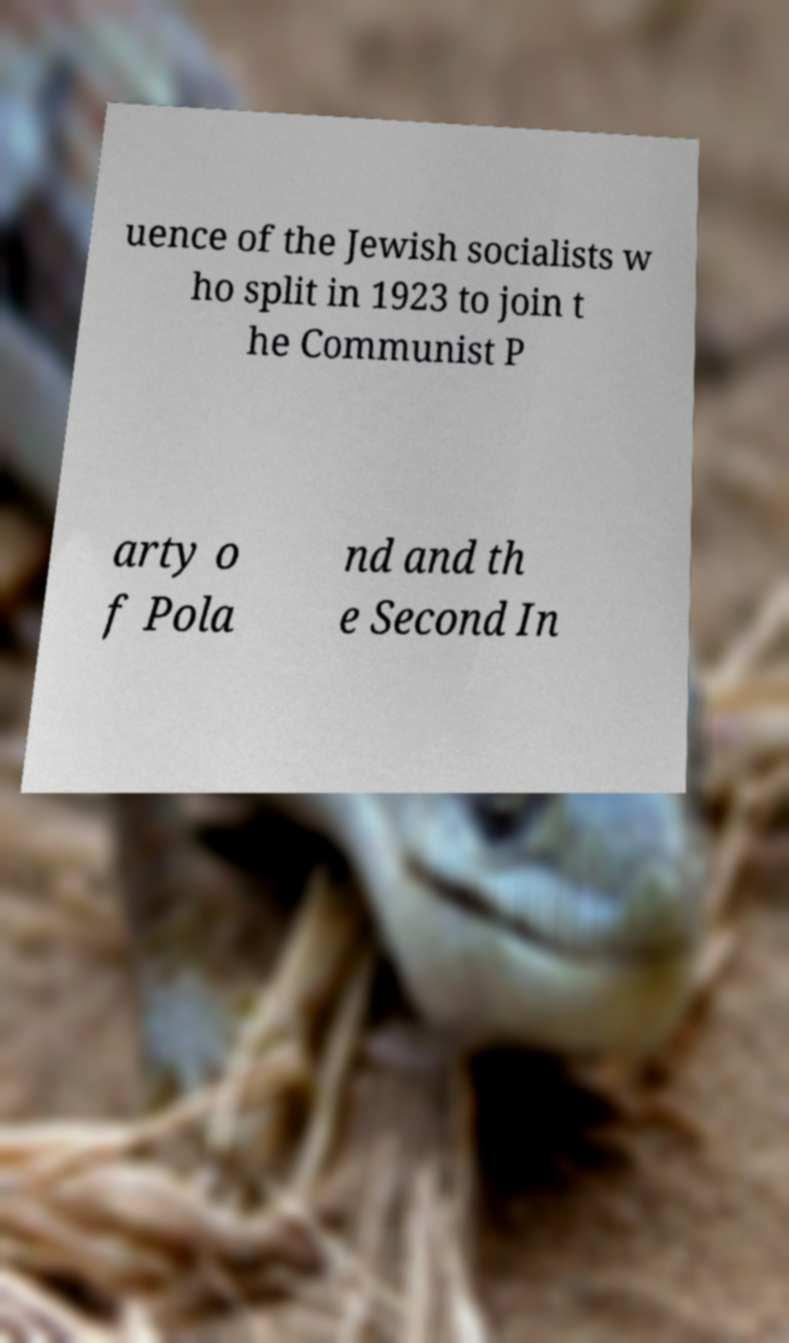What messages or text are displayed in this image? I need them in a readable, typed format. uence of the Jewish socialists w ho split in 1923 to join t he Communist P arty o f Pola nd and th e Second In 